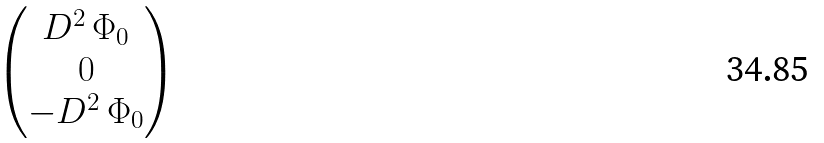<formula> <loc_0><loc_0><loc_500><loc_500>\begin{pmatrix} D ^ { 2 } \, \Phi _ { 0 } \\ 0 \\ - D ^ { 2 } \, \Phi _ { 0 } \end{pmatrix}</formula> 